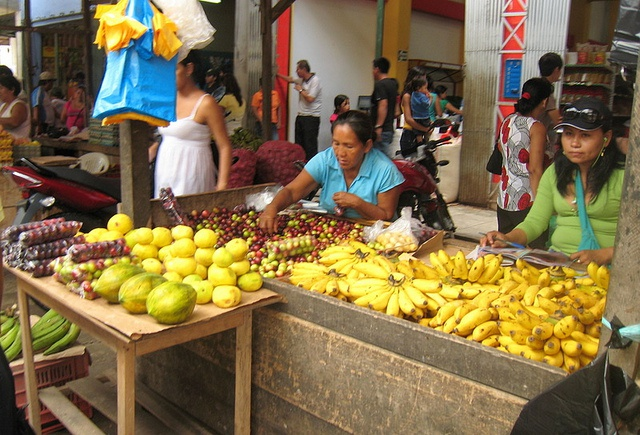Describe the objects in this image and their specific colors. I can see banana in gray, khaki, orange, gold, and olive tones, people in gray, black, olive, and brown tones, people in gray, maroon, brown, black, and teal tones, people in gray, lightgray, darkgray, and brown tones, and people in gray, black, darkgray, maroon, and brown tones in this image. 